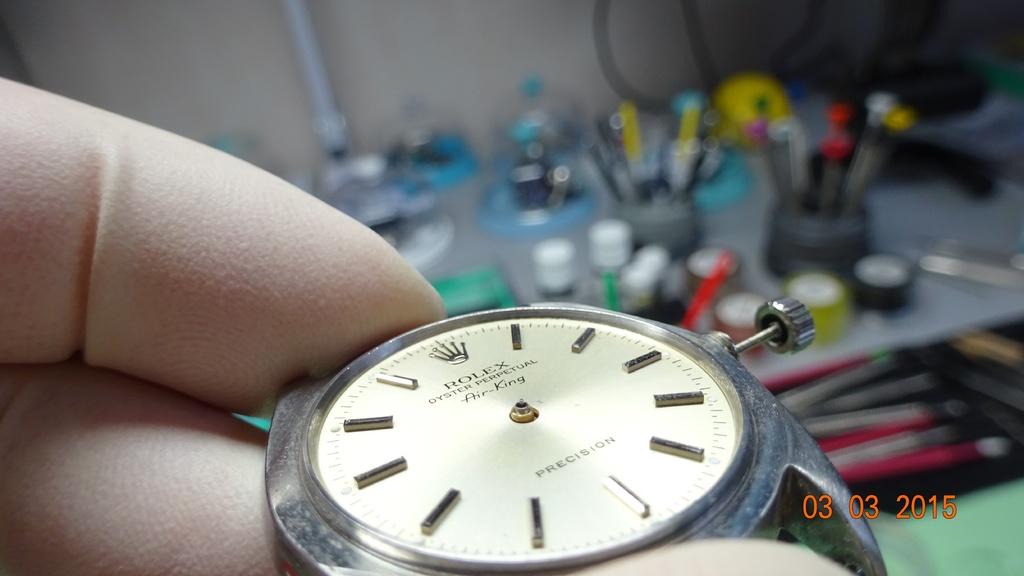What is printed on the bottom half of the watch face?
Offer a terse response. Precision. 